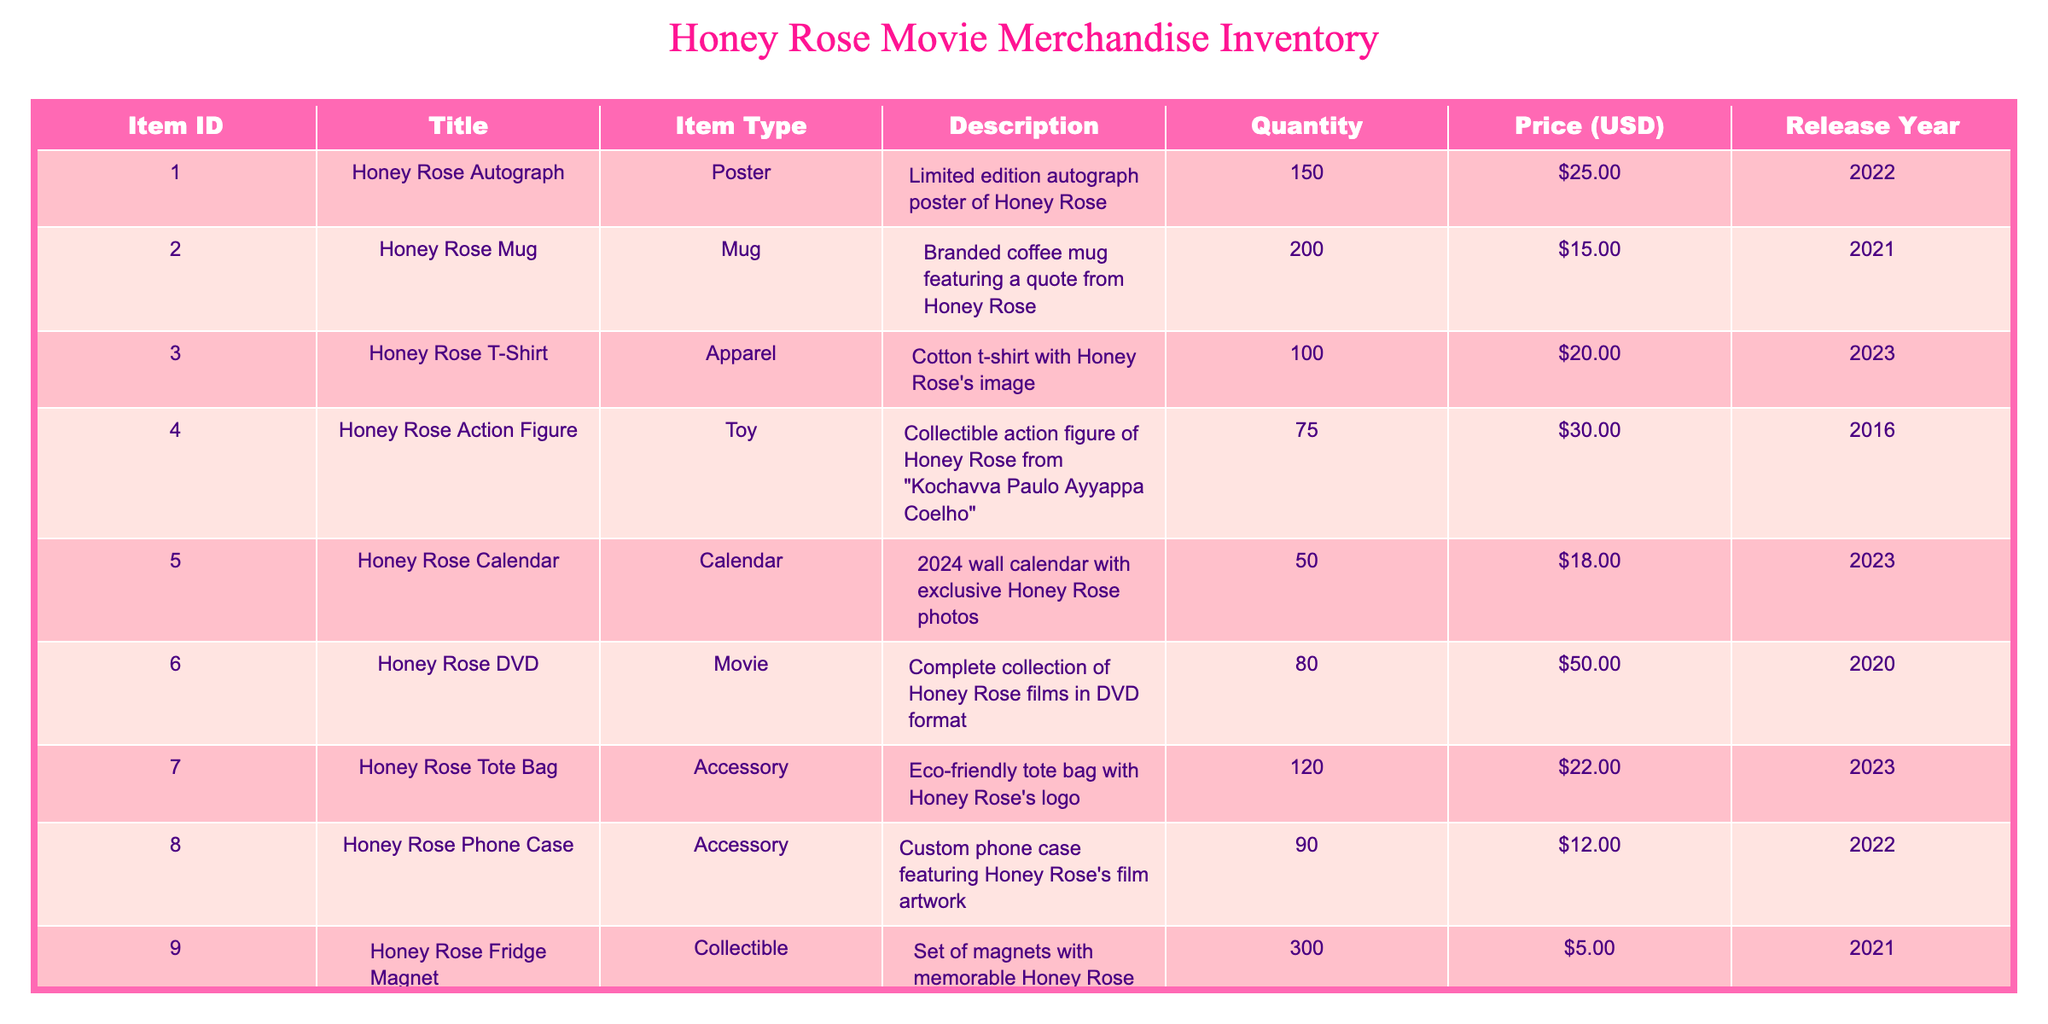What is the price of the Honey Rose T-Shirt? The price of the Honey Rose T-Shirt can be found directly under the Price column for its corresponding row, which shows $20.00.
Answer: $20.00 How many items of Honey Rose Autograph posters are available? From the Quantity column for the Honey Rose Autograph row, the available quantity is 150.
Answer: 150 What is the total quantity of Honey Rose merchandise available? To find the total quantity, sum all the quantities from the Quantity column: 150 + 200 + 100 + 75 + 50 + 80 + 120 + 90 + 300 + 40 = 1,105.
Answer: 1,105 Are there more Honey Rose Fridge Magnets than Honey Rose Calendars? Comparing the quantities in the corresponding rows, Honey Rose Fridge Magnets have 300, and Honey Rose Calendars have 50. Since 300 > 50, the answer is yes.
Answer: Yes What is the average price of Honey Rose merchandise listed in the inventory? To find the average price, sum the prices of all items: (25 + 15 + 20 + 30 + 18 + 50 + 22 + 12 + 5 + 45) =  232. Dividing by the number of items (10): 232 / 10 = 23.20.
Answer: $23.20 Which item has the highest price? Reviewing the Price column, the Honey Rose DVD is priced at $50.00, which is higher than any other item's price in the list.
Answer: Honey Rose DVD How many items were released in 2023? Looking at the Release Year column, the items released in 2023 are the Honey Rose T-Shirt, Calendar, Tote Bag, and Signature Perfume, which accounts for 4 items.
Answer: 4 Is there a Honey Rose item that was released in both 2022 and 2023? Checking the Release Year column, we see that the Honey Rose Mug was released in 2021 and the Honey Rose Phone Case in 2022. The items from 2023 are distinct; therefore, the correct answer is no.
Answer: No What is the total revenue generated if all 150 Honey Rose Autograph posters were sold? To calculate the total revenue, multiply the quantity of Honey Rose Autograph posters (150) by the price ($25): 150 * 25 = 3,750.
Answer: $3,750 